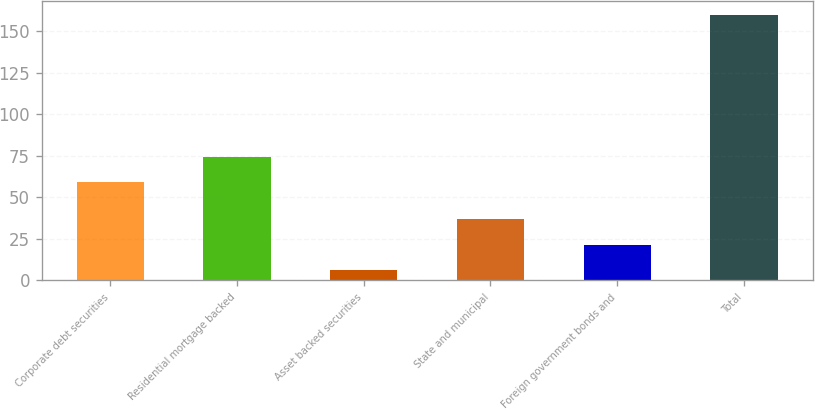<chart> <loc_0><loc_0><loc_500><loc_500><bar_chart><fcel>Corporate debt securities<fcel>Residential mortgage backed<fcel>Asset backed securities<fcel>State and municipal<fcel>Foreign government bonds and<fcel>Total<nl><fcel>59<fcel>74.4<fcel>6<fcel>36.8<fcel>21.4<fcel>160<nl></chart> 